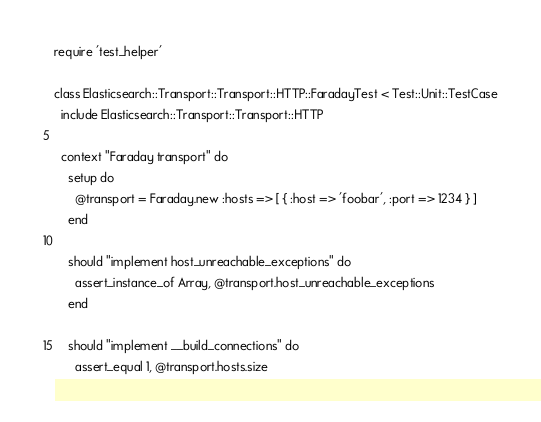Convert code to text. <code><loc_0><loc_0><loc_500><loc_500><_Ruby_>require 'test_helper'

class Elasticsearch::Transport::Transport::HTTP::FaradayTest < Test::Unit::TestCase
  include Elasticsearch::Transport::Transport::HTTP

  context "Faraday transport" do
    setup do
      @transport = Faraday.new :hosts => [ { :host => 'foobar', :port => 1234 } ]
    end

    should "implement host_unreachable_exceptions" do
      assert_instance_of Array, @transport.host_unreachable_exceptions
    end

    should "implement __build_connections" do
      assert_equal 1, @transport.hosts.size</code> 